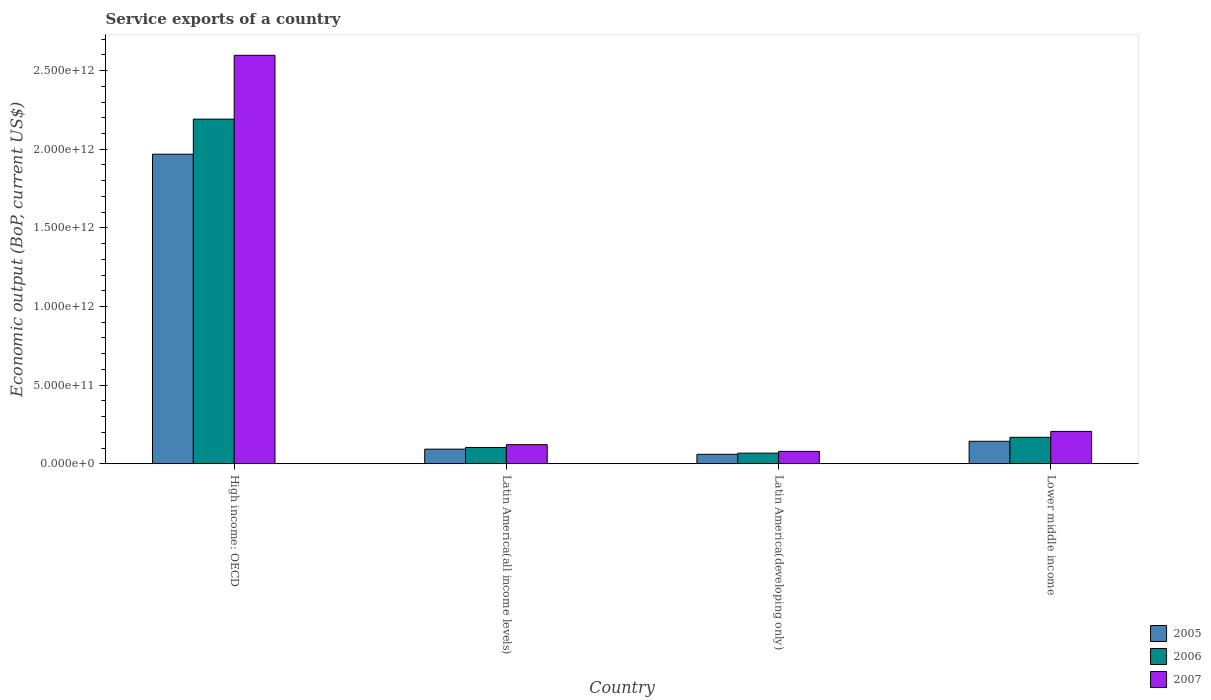Are the number of bars per tick equal to the number of legend labels?
Provide a succinct answer. Yes. Are the number of bars on each tick of the X-axis equal?
Ensure brevity in your answer.  Yes. How many bars are there on the 3rd tick from the left?
Your answer should be very brief. 3. How many bars are there on the 2nd tick from the right?
Provide a short and direct response. 3. What is the label of the 3rd group of bars from the left?
Offer a very short reply. Latin America(developing only). In how many cases, is the number of bars for a given country not equal to the number of legend labels?
Your response must be concise. 0. What is the service exports in 2006 in Lower middle income?
Provide a short and direct response. 1.68e+11. Across all countries, what is the maximum service exports in 2007?
Give a very brief answer. 2.60e+12. Across all countries, what is the minimum service exports in 2005?
Your response must be concise. 6.00e+1. In which country was the service exports in 2007 maximum?
Your answer should be very brief. High income: OECD. In which country was the service exports in 2007 minimum?
Give a very brief answer. Latin America(developing only). What is the total service exports in 2005 in the graph?
Your answer should be very brief. 2.26e+12. What is the difference between the service exports in 2005 in Latin America(developing only) and that in Lower middle income?
Your answer should be very brief. -8.27e+1. What is the difference between the service exports in 2005 in Latin America(developing only) and the service exports in 2007 in Latin America(all income levels)?
Your response must be concise. -6.14e+1. What is the average service exports in 2006 per country?
Make the answer very short. 6.33e+11. What is the difference between the service exports of/in 2006 and service exports of/in 2007 in Latin America(all income levels)?
Provide a short and direct response. -1.79e+1. In how many countries, is the service exports in 2006 greater than 700000000000 US$?
Ensure brevity in your answer.  1. What is the ratio of the service exports in 2006 in High income: OECD to that in Lower middle income?
Your answer should be compact. 13.03. Is the difference between the service exports in 2006 in Latin America(all income levels) and Lower middle income greater than the difference between the service exports in 2007 in Latin America(all income levels) and Lower middle income?
Offer a terse response. Yes. What is the difference between the highest and the second highest service exports in 2007?
Provide a short and direct response. 8.42e+1. What is the difference between the highest and the lowest service exports in 2005?
Your answer should be compact. 1.91e+12. In how many countries, is the service exports in 2006 greater than the average service exports in 2006 taken over all countries?
Your answer should be very brief. 1. Are all the bars in the graph horizontal?
Keep it short and to the point. No. How many countries are there in the graph?
Keep it short and to the point. 4. What is the difference between two consecutive major ticks on the Y-axis?
Keep it short and to the point. 5.00e+11. Are the values on the major ticks of Y-axis written in scientific E-notation?
Give a very brief answer. Yes. Where does the legend appear in the graph?
Provide a short and direct response. Bottom right. How are the legend labels stacked?
Provide a short and direct response. Vertical. What is the title of the graph?
Offer a very short reply. Service exports of a country. What is the label or title of the X-axis?
Offer a very short reply. Country. What is the label or title of the Y-axis?
Your answer should be compact. Economic output (BoP, current US$). What is the Economic output (BoP, current US$) of 2005 in High income: OECD?
Your answer should be very brief. 1.97e+12. What is the Economic output (BoP, current US$) in 2006 in High income: OECD?
Keep it short and to the point. 2.19e+12. What is the Economic output (BoP, current US$) of 2007 in High income: OECD?
Offer a very short reply. 2.60e+12. What is the Economic output (BoP, current US$) in 2005 in Latin America(all income levels)?
Ensure brevity in your answer.  9.28e+1. What is the Economic output (BoP, current US$) in 2006 in Latin America(all income levels)?
Provide a short and direct response. 1.04e+11. What is the Economic output (BoP, current US$) of 2007 in Latin America(all income levels)?
Keep it short and to the point. 1.21e+11. What is the Economic output (BoP, current US$) of 2005 in Latin America(developing only)?
Make the answer very short. 6.00e+1. What is the Economic output (BoP, current US$) of 2006 in Latin America(developing only)?
Offer a terse response. 6.73e+1. What is the Economic output (BoP, current US$) of 2007 in Latin America(developing only)?
Your response must be concise. 7.86e+1. What is the Economic output (BoP, current US$) of 2005 in Lower middle income?
Give a very brief answer. 1.43e+11. What is the Economic output (BoP, current US$) in 2006 in Lower middle income?
Your answer should be compact. 1.68e+11. What is the Economic output (BoP, current US$) of 2007 in Lower middle income?
Your response must be concise. 2.06e+11. Across all countries, what is the maximum Economic output (BoP, current US$) in 2005?
Ensure brevity in your answer.  1.97e+12. Across all countries, what is the maximum Economic output (BoP, current US$) in 2006?
Your answer should be compact. 2.19e+12. Across all countries, what is the maximum Economic output (BoP, current US$) of 2007?
Provide a short and direct response. 2.60e+12. Across all countries, what is the minimum Economic output (BoP, current US$) in 2005?
Offer a terse response. 6.00e+1. Across all countries, what is the minimum Economic output (BoP, current US$) of 2006?
Ensure brevity in your answer.  6.73e+1. Across all countries, what is the minimum Economic output (BoP, current US$) of 2007?
Provide a short and direct response. 7.86e+1. What is the total Economic output (BoP, current US$) in 2005 in the graph?
Keep it short and to the point. 2.26e+12. What is the total Economic output (BoP, current US$) in 2006 in the graph?
Provide a short and direct response. 2.53e+12. What is the total Economic output (BoP, current US$) in 2007 in the graph?
Make the answer very short. 3.00e+12. What is the difference between the Economic output (BoP, current US$) in 2005 in High income: OECD and that in Latin America(all income levels)?
Offer a terse response. 1.88e+12. What is the difference between the Economic output (BoP, current US$) in 2006 in High income: OECD and that in Latin America(all income levels)?
Give a very brief answer. 2.09e+12. What is the difference between the Economic output (BoP, current US$) of 2007 in High income: OECD and that in Latin America(all income levels)?
Provide a succinct answer. 2.48e+12. What is the difference between the Economic output (BoP, current US$) of 2005 in High income: OECD and that in Latin America(developing only)?
Provide a short and direct response. 1.91e+12. What is the difference between the Economic output (BoP, current US$) in 2006 in High income: OECD and that in Latin America(developing only)?
Provide a succinct answer. 2.12e+12. What is the difference between the Economic output (BoP, current US$) of 2007 in High income: OECD and that in Latin America(developing only)?
Your answer should be compact. 2.52e+12. What is the difference between the Economic output (BoP, current US$) in 2005 in High income: OECD and that in Lower middle income?
Ensure brevity in your answer.  1.83e+12. What is the difference between the Economic output (BoP, current US$) in 2006 in High income: OECD and that in Lower middle income?
Your response must be concise. 2.02e+12. What is the difference between the Economic output (BoP, current US$) in 2007 in High income: OECD and that in Lower middle income?
Provide a short and direct response. 2.39e+12. What is the difference between the Economic output (BoP, current US$) of 2005 in Latin America(all income levels) and that in Latin America(developing only)?
Ensure brevity in your answer.  3.27e+1. What is the difference between the Economic output (BoP, current US$) in 2006 in Latin America(all income levels) and that in Latin America(developing only)?
Keep it short and to the point. 3.62e+1. What is the difference between the Economic output (BoP, current US$) in 2007 in Latin America(all income levels) and that in Latin America(developing only)?
Keep it short and to the point. 4.29e+1. What is the difference between the Economic output (BoP, current US$) in 2005 in Latin America(all income levels) and that in Lower middle income?
Give a very brief answer. -4.99e+1. What is the difference between the Economic output (BoP, current US$) in 2006 in Latin America(all income levels) and that in Lower middle income?
Give a very brief answer. -6.46e+1. What is the difference between the Economic output (BoP, current US$) of 2007 in Latin America(all income levels) and that in Lower middle income?
Make the answer very short. -8.42e+1. What is the difference between the Economic output (BoP, current US$) of 2005 in Latin America(developing only) and that in Lower middle income?
Offer a terse response. -8.27e+1. What is the difference between the Economic output (BoP, current US$) in 2006 in Latin America(developing only) and that in Lower middle income?
Your response must be concise. -1.01e+11. What is the difference between the Economic output (BoP, current US$) in 2007 in Latin America(developing only) and that in Lower middle income?
Offer a very short reply. -1.27e+11. What is the difference between the Economic output (BoP, current US$) in 2005 in High income: OECD and the Economic output (BoP, current US$) in 2006 in Latin America(all income levels)?
Ensure brevity in your answer.  1.86e+12. What is the difference between the Economic output (BoP, current US$) of 2005 in High income: OECD and the Economic output (BoP, current US$) of 2007 in Latin America(all income levels)?
Keep it short and to the point. 1.85e+12. What is the difference between the Economic output (BoP, current US$) of 2006 in High income: OECD and the Economic output (BoP, current US$) of 2007 in Latin America(all income levels)?
Make the answer very short. 2.07e+12. What is the difference between the Economic output (BoP, current US$) of 2005 in High income: OECD and the Economic output (BoP, current US$) of 2006 in Latin America(developing only)?
Your response must be concise. 1.90e+12. What is the difference between the Economic output (BoP, current US$) of 2005 in High income: OECD and the Economic output (BoP, current US$) of 2007 in Latin America(developing only)?
Keep it short and to the point. 1.89e+12. What is the difference between the Economic output (BoP, current US$) of 2006 in High income: OECD and the Economic output (BoP, current US$) of 2007 in Latin America(developing only)?
Offer a terse response. 2.11e+12. What is the difference between the Economic output (BoP, current US$) of 2005 in High income: OECD and the Economic output (BoP, current US$) of 2006 in Lower middle income?
Offer a very short reply. 1.80e+12. What is the difference between the Economic output (BoP, current US$) in 2005 in High income: OECD and the Economic output (BoP, current US$) in 2007 in Lower middle income?
Your answer should be compact. 1.76e+12. What is the difference between the Economic output (BoP, current US$) in 2006 in High income: OECD and the Economic output (BoP, current US$) in 2007 in Lower middle income?
Offer a terse response. 1.99e+12. What is the difference between the Economic output (BoP, current US$) in 2005 in Latin America(all income levels) and the Economic output (BoP, current US$) in 2006 in Latin America(developing only)?
Ensure brevity in your answer.  2.55e+1. What is the difference between the Economic output (BoP, current US$) of 2005 in Latin America(all income levels) and the Economic output (BoP, current US$) of 2007 in Latin America(developing only)?
Keep it short and to the point. 1.42e+1. What is the difference between the Economic output (BoP, current US$) in 2006 in Latin America(all income levels) and the Economic output (BoP, current US$) in 2007 in Latin America(developing only)?
Provide a short and direct response. 2.50e+1. What is the difference between the Economic output (BoP, current US$) in 2005 in Latin America(all income levels) and the Economic output (BoP, current US$) in 2006 in Lower middle income?
Provide a succinct answer. -7.54e+1. What is the difference between the Economic output (BoP, current US$) in 2005 in Latin America(all income levels) and the Economic output (BoP, current US$) in 2007 in Lower middle income?
Your response must be concise. -1.13e+11. What is the difference between the Economic output (BoP, current US$) of 2006 in Latin America(all income levels) and the Economic output (BoP, current US$) of 2007 in Lower middle income?
Your answer should be very brief. -1.02e+11. What is the difference between the Economic output (BoP, current US$) of 2005 in Latin America(developing only) and the Economic output (BoP, current US$) of 2006 in Lower middle income?
Give a very brief answer. -1.08e+11. What is the difference between the Economic output (BoP, current US$) of 2005 in Latin America(developing only) and the Economic output (BoP, current US$) of 2007 in Lower middle income?
Offer a very short reply. -1.46e+11. What is the difference between the Economic output (BoP, current US$) in 2006 in Latin America(developing only) and the Economic output (BoP, current US$) in 2007 in Lower middle income?
Make the answer very short. -1.38e+11. What is the average Economic output (BoP, current US$) of 2005 per country?
Provide a short and direct response. 5.66e+11. What is the average Economic output (BoP, current US$) in 2006 per country?
Keep it short and to the point. 6.33e+11. What is the average Economic output (BoP, current US$) in 2007 per country?
Provide a succinct answer. 7.51e+11. What is the difference between the Economic output (BoP, current US$) of 2005 and Economic output (BoP, current US$) of 2006 in High income: OECD?
Offer a very short reply. -2.23e+11. What is the difference between the Economic output (BoP, current US$) in 2005 and Economic output (BoP, current US$) in 2007 in High income: OECD?
Your response must be concise. -6.29e+11. What is the difference between the Economic output (BoP, current US$) of 2006 and Economic output (BoP, current US$) of 2007 in High income: OECD?
Provide a succinct answer. -4.06e+11. What is the difference between the Economic output (BoP, current US$) in 2005 and Economic output (BoP, current US$) in 2006 in Latin America(all income levels)?
Give a very brief answer. -1.08e+1. What is the difference between the Economic output (BoP, current US$) of 2005 and Economic output (BoP, current US$) of 2007 in Latin America(all income levels)?
Provide a succinct answer. -2.87e+1. What is the difference between the Economic output (BoP, current US$) in 2006 and Economic output (BoP, current US$) in 2007 in Latin America(all income levels)?
Your response must be concise. -1.79e+1. What is the difference between the Economic output (BoP, current US$) in 2005 and Economic output (BoP, current US$) in 2006 in Latin America(developing only)?
Make the answer very short. -7.28e+09. What is the difference between the Economic output (BoP, current US$) in 2005 and Economic output (BoP, current US$) in 2007 in Latin America(developing only)?
Your answer should be very brief. -1.86e+1. What is the difference between the Economic output (BoP, current US$) in 2006 and Economic output (BoP, current US$) in 2007 in Latin America(developing only)?
Offer a terse response. -1.13e+1. What is the difference between the Economic output (BoP, current US$) of 2005 and Economic output (BoP, current US$) of 2006 in Lower middle income?
Give a very brief answer. -2.54e+1. What is the difference between the Economic output (BoP, current US$) in 2005 and Economic output (BoP, current US$) in 2007 in Lower middle income?
Offer a very short reply. -6.29e+1. What is the difference between the Economic output (BoP, current US$) of 2006 and Economic output (BoP, current US$) of 2007 in Lower middle income?
Your answer should be very brief. -3.75e+1. What is the ratio of the Economic output (BoP, current US$) in 2005 in High income: OECD to that in Latin America(all income levels)?
Make the answer very short. 21.22. What is the ratio of the Economic output (BoP, current US$) of 2006 in High income: OECD to that in Latin America(all income levels)?
Provide a succinct answer. 21.16. What is the ratio of the Economic output (BoP, current US$) of 2007 in High income: OECD to that in Latin America(all income levels)?
Your answer should be compact. 21.39. What is the ratio of the Economic output (BoP, current US$) of 2005 in High income: OECD to that in Latin America(developing only)?
Make the answer very short. 32.79. What is the ratio of the Economic output (BoP, current US$) in 2006 in High income: OECD to that in Latin America(developing only)?
Give a very brief answer. 32.56. What is the ratio of the Economic output (BoP, current US$) of 2007 in High income: OECD to that in Latin America(developing only)?
Give a very brief answer. 33.05. What is the ratio of the Economic output (BoP, current US$) of 2005 in High income: OECD to that in Lower middle income?
Provide a short and direct response. 13.79. What is the ratio of the Economic output (BoP, current US$) of 2006 in High income: OECD to that in Lower middle income?
Provide a succinct answer. 13.03. What is the ratio of the Economic output (BoP, current US$) in 2007 in High income: OECD to that in Lower middle income?
Provide a succinct answer. 12.63. What is the ratio of the Economic output (BoP, current US$) in 2005 in Latin America(all income levels) to that in Latin America(developing only)?
Make the answer very short. 1.55. What is the ratio of the Economic output (BoP, current US$) in 2006 in Latin America(all income levels) to that in Latin America(developing only)?
Your answer should be compact. 1.54. What is the ratio of the Economic output (BoP, current US$) of 2007 in Latin America(all income levels) to that in Latin America(developing only)?
Give a very brief answer. 1.55. What is the ratio of the Economic output (BoP, current US$) of 2005 in Latin America(all income levels) to that in Lower middle income?
Offer a terse response. 0.65. What is the ratio of the Economic output (BoP, current US$) in 2006 in Latin America(all income levels) to that in Lower middle income?
Offer a terse response. 0.62. What is the ratio of the Economic output (BoP, current US$) in 2007 in Latin America(all income levels) to that in Lower middle income?
Offer a terse response. 0.59. What is the ratio of the Economic output (BoP, current US$) of 2005 in Latin America(developing only) to that in Lower middle income?
Give a very brief answer. 0.42. What is the ratio of the Economic output (BoP, current US$) of 2006 in Latin America(developing only) to that in Lower middle income?
Provide a succinct answer. 0.4. What is the ratio of the Economic output (BoP, current US$) in 2007 in Latin America(developing only) to that in Lower middle income?
Offer a very short reply. 0.38. What is the difference between the highest and the second highest Economic output (BoP, current US$) in 2005?
Give a very brief answer. 1.83e+12. What is the difference between the highest and the second highest Economic output (BoP, current US$) of 2006?
Offer a terse response. 2.02e+12. What is the difference between the highest and the second highest Economic output (BoP, current US$) in 2007?
Give a very brief answer. 2.39e+12. What is the difference between the highest and the lowest Economic output (BoP, current US$) of 2005?
Give a very brief answer. 1.91e+12. What is the difference between the highest and the lowest Economic output (BoP, current US$) of 2006?
Offer a very short reply. 2.12e+12. What is the difference between the highest and the lowest Economic output (BoP, current US$) of 2007?
Keep it short and to the point. 2.52e+12. 